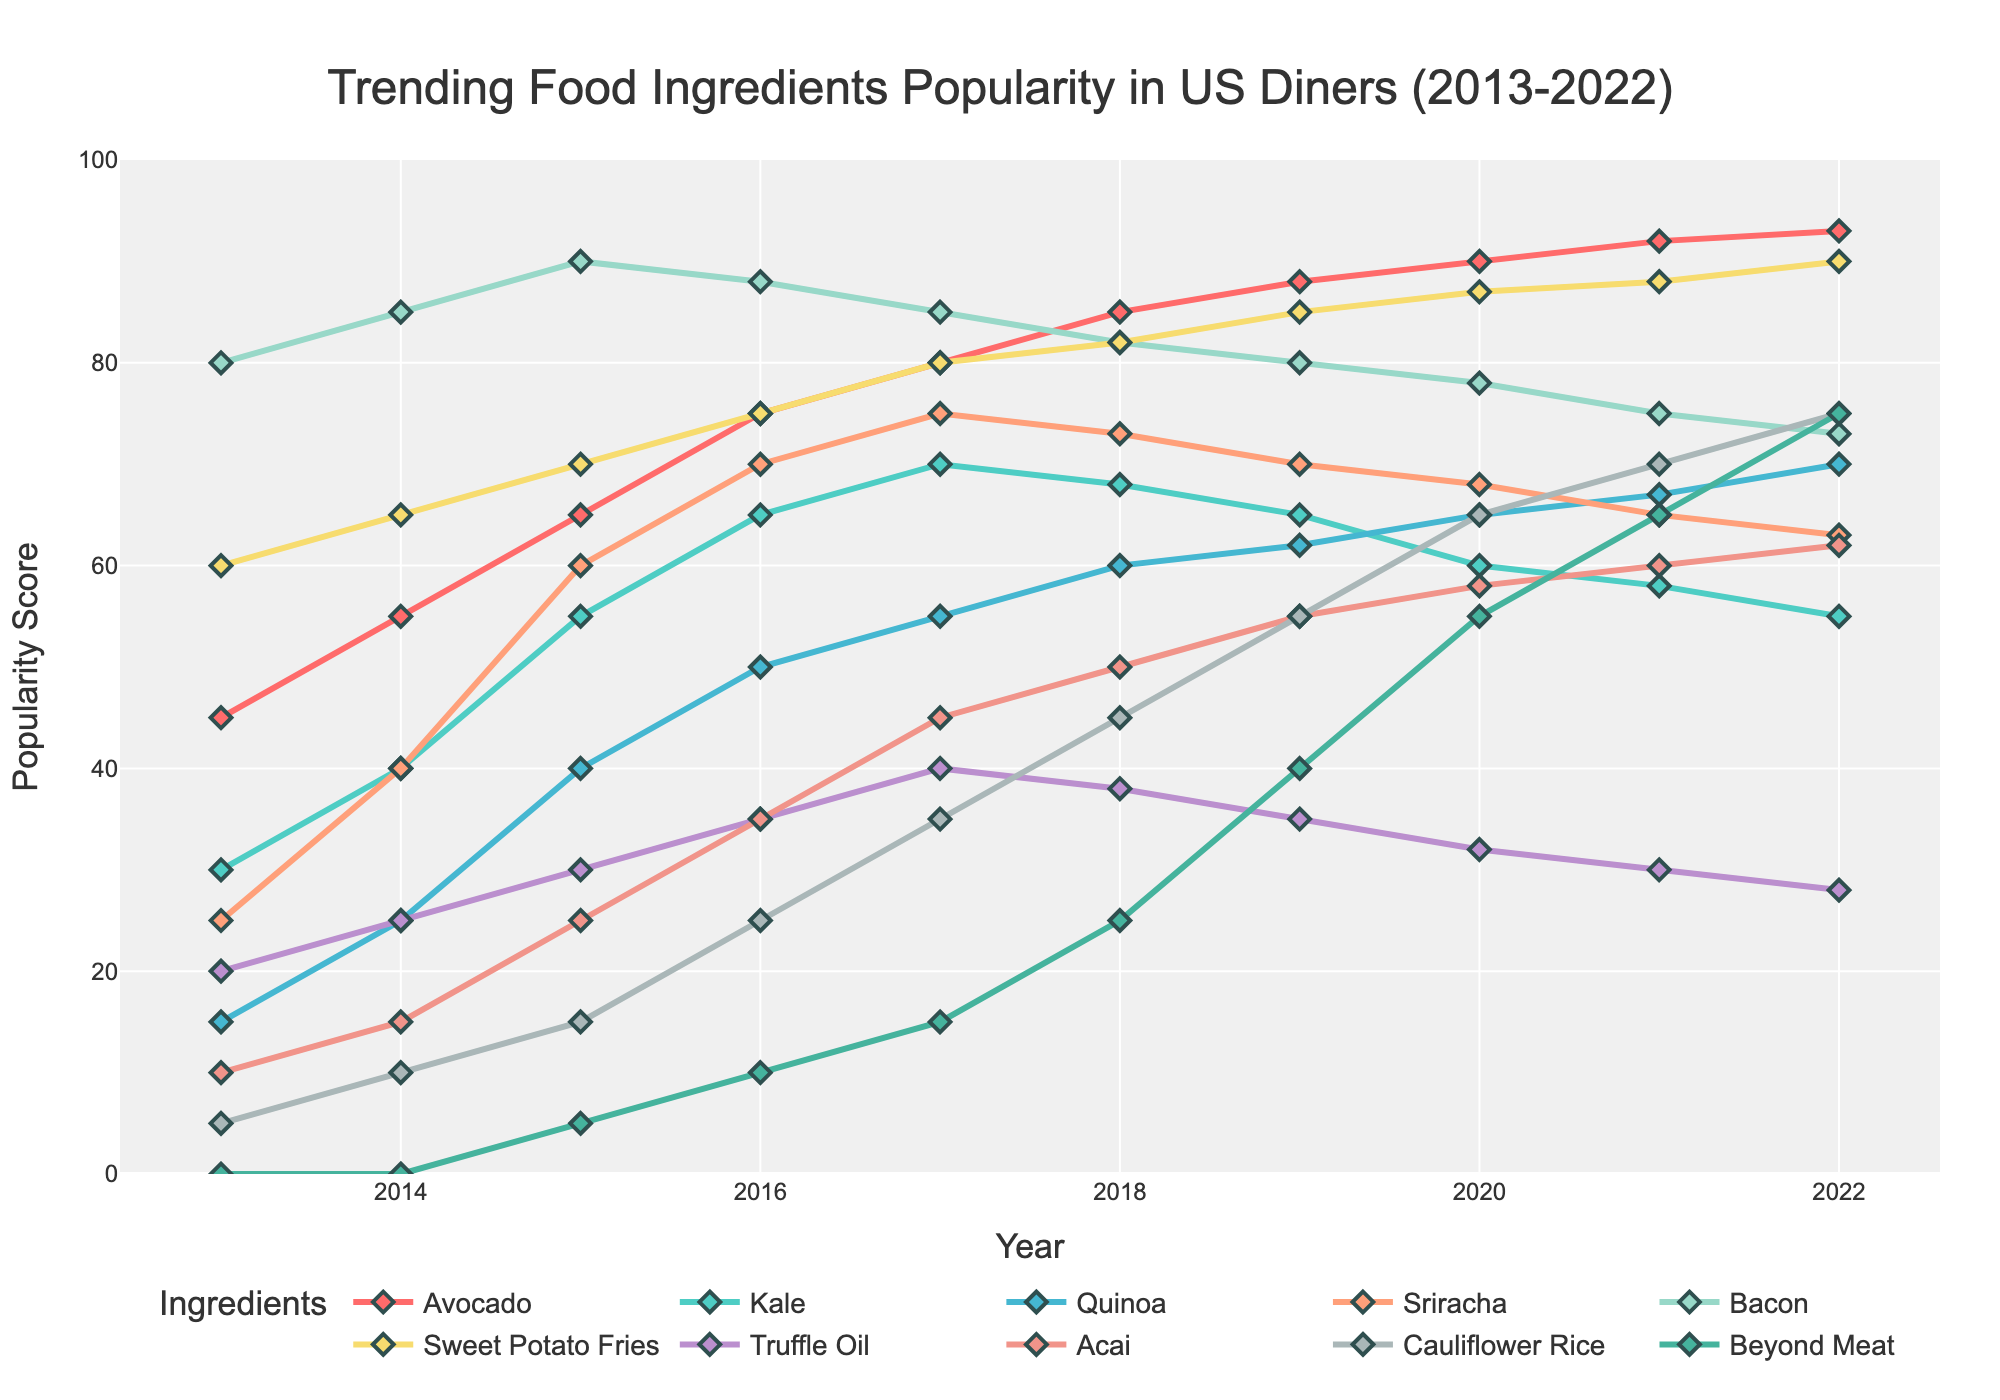What ingredient saw the highest increase in popularity from 2013 to 2022? Look at the starting and ending points for each ingredient and find the one with the largest increase in popularity score. Avocado started at 45 and ended at 93, an increase of 48.
Answer: Avocado Which ingredient had a consistent growth trend throughout the decade? Analyze each ingredient's trend line and identify which ones increased in value consistently every year. Avocado shows a consistent upward trend every year.
Answer: Avocado Between 2017 and 2022, which ingredient's popularity decreased the most? Compare the popularity scores of each ingredient in 2017 and 2022, and then calculate the difference (decrease) for each ingredient. Kale decreased from 70 to 55, a decrease of 15 points.
Answer: Kale How many ingredients had their highest popularity score in 2022? Review the ending (2022) points of each ingredient’s trend line and count how many had their highest score that year. Beyond Meat, Cauliflower Rice, Sweet Potato Fries, and Quinoa all had their highest scores in 2022.
Answer: 4 Which ingredient had a peak popularity score in 2017 and then declined? Look for ingredients whose scores peaked in 2017 and then consistently declined thereafter. Sriracha peaked at 75 in 2017 and then declined.
Answer: Sriracha Between Avocado and Bacon, which ingredient had a higher score in 2020? Compare the popularity scores of Avocado and Bacon in the year 2020. Avocado had a score of 90, while Bacon had a score of 78.
Answer: Avocado Which two ingredients had the closest popularity scores in 2016? Compare popularity scores of all ingredients in 2016 to identify the closest pair. Kale and Sweet Potato Fries had scores of 65 and 75, which are 10 points apart.
Answer: Kale and Sweet Potato Fries What is the average popularity score of Kale from 2013 to 2022? Add up the popularity scores of Kale over these years and divide by the number of years. (30+40+55+65+70+68+65+60+58+55) = 566. 566/10 = 56.6.
Answer: 56.6 Which ingredient had the most significant drop from 2018 to 2019? Calculate the difference in popularity scores for each ingredient between 2018 and 2019. Kale dropped from 68 to 65, a decrease of 3 points.
Answer: Kale In which year did Sweet Potato Fries surpass Bacon in popularity? Trace both the lines of Sweet Potato Fries and Bacon to find the first year where the Sweet Potato Fries score exceeded that of Bacon. In 2022, Sweet Potato Fries (90) surpassed Bacon (73).
Answer: 2022 